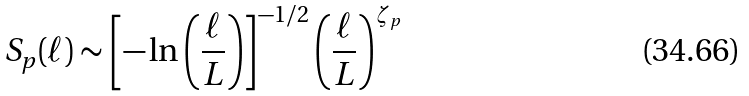<formula> <loc_0><loc_0><loc_500><loc_500>S _ { p } ( \ell ) \sim \left [ - \ln \left ( \frac { \ell } { L } \right ) \right ] ^ { - 1 / 2 } \left ( \frac { \ell } { L } \right ) ^ { \zeta _ { p } }</formula> 